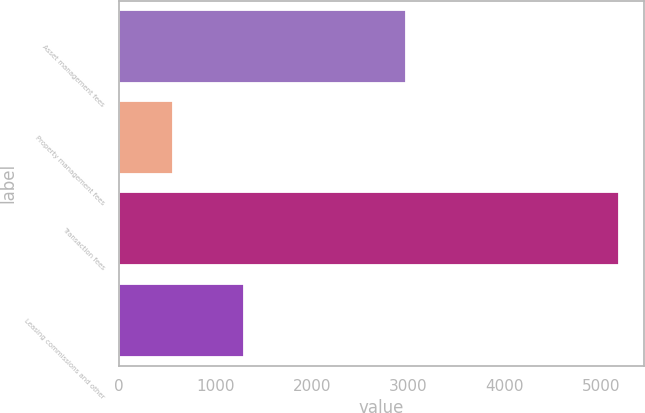Convert chart. <chart><loc_0><loc_0><loc_500><loc_500><bar_chart><fcel>Asset management fees<fcel>Property management fees<fcel>Transaction fees<fcel>Leasing commissions and other<nl><fcel>2976<fcel>568<fcel>5187<fcel>1294<nl></chart> 